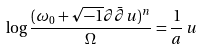<formula> <loc_0><loc_0><loc_500><loc_500>\log \frac { ( \omega _ { 0 } + \sqrt { - 1 } \partial \bar { \partial } u ) ^ { n } } { \Omega } = \frac { 1 } { a } \, u</formula> 